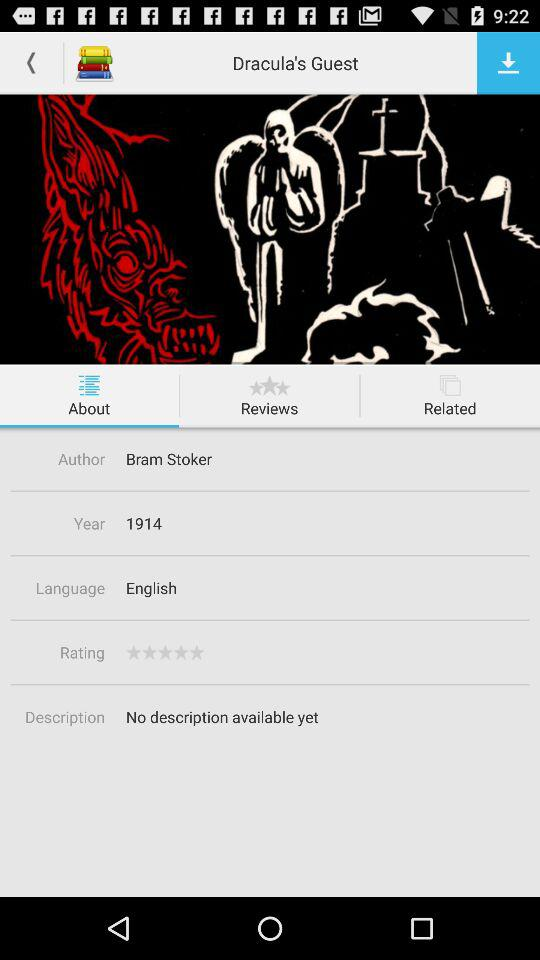What is the author name? The author name is Bram Stoker. 